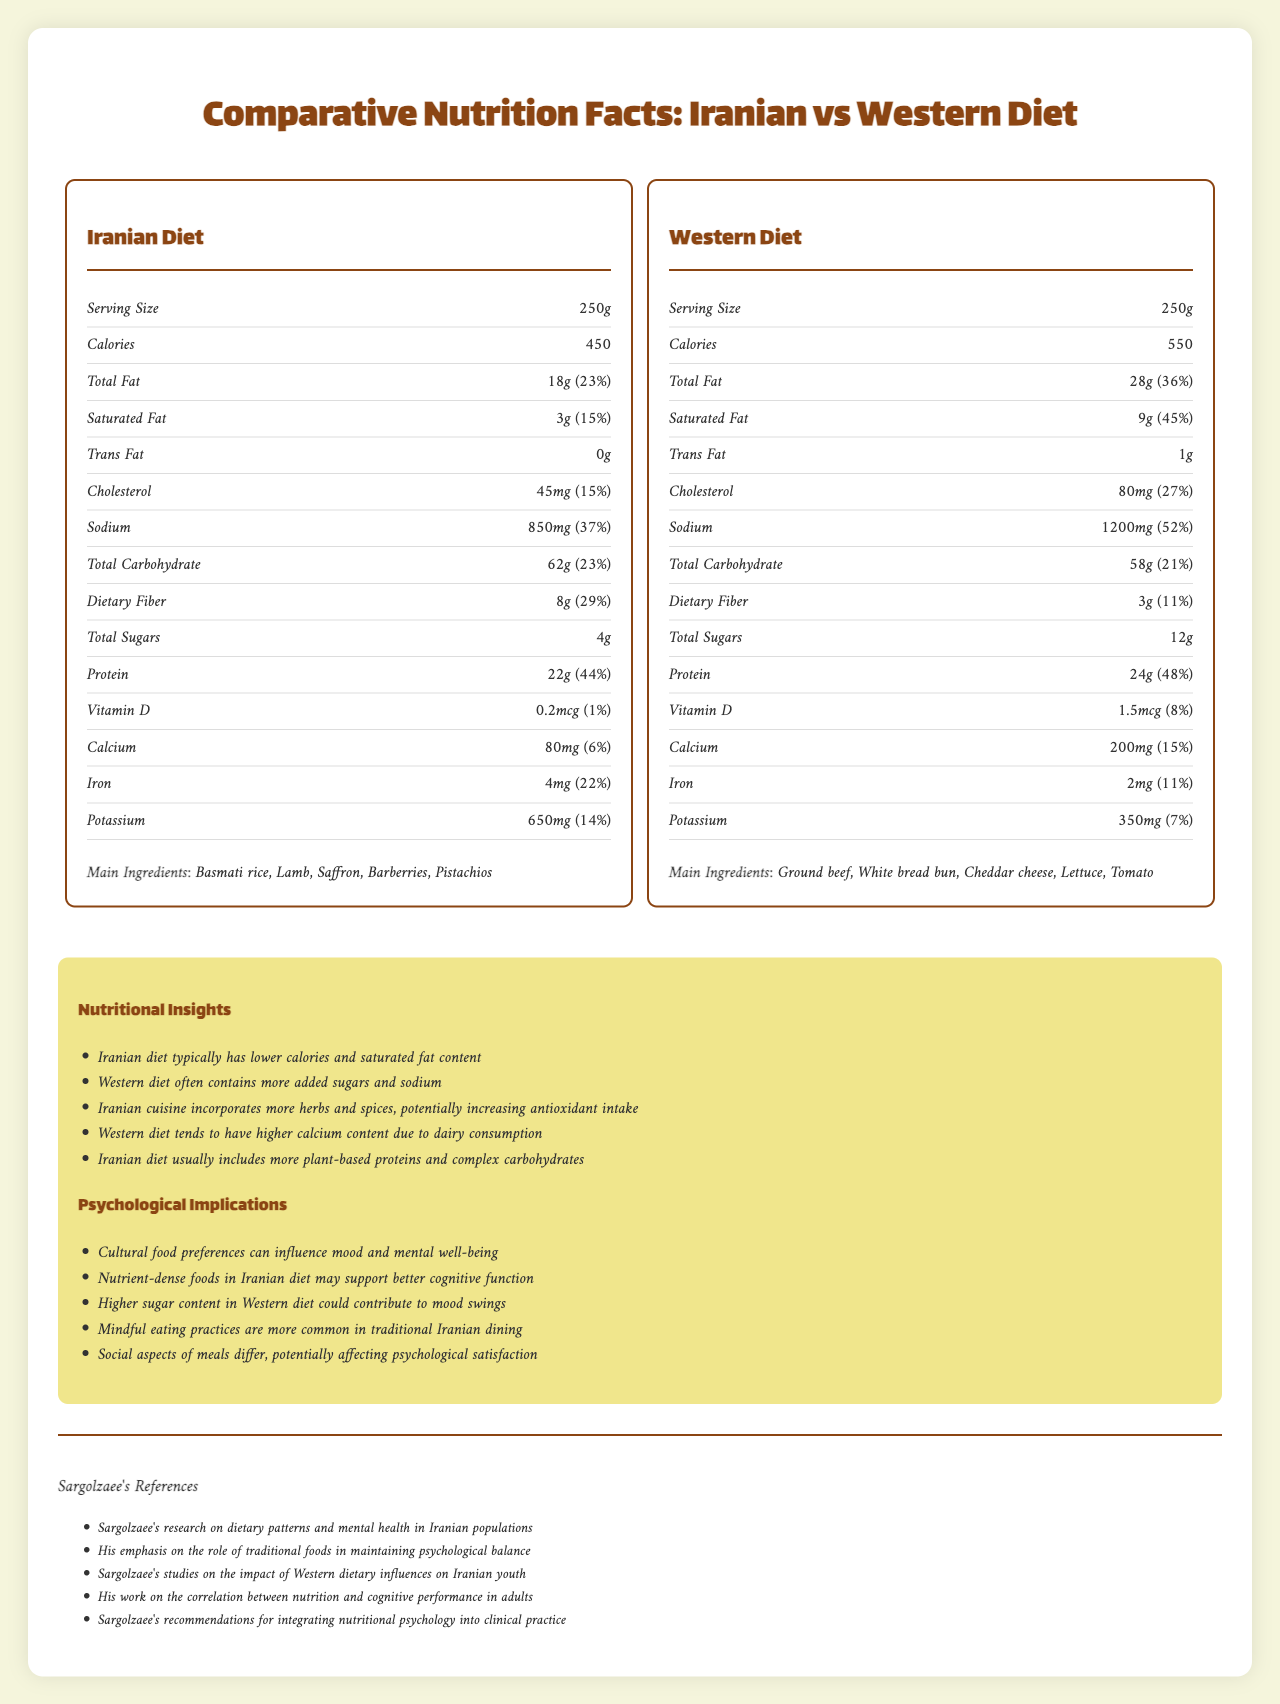what is the serving size for the Iranian diet? The serving size for the Iranian diet is indicated as 250g in the label for the Iranian Diet section.
Answer: 250g What is the amount of protein in the Western diet? The amount of protein in the Western diet is shown to be 24g in the label for the Western Diet section.
Answer: 24g How much dietary fiber is in the Iranian diet? The amount of dietary fiber in the Iranian diet can be found as 8g in the label.
Answer: 8g Which diet has a higher sodium content? A. Iranian Diet B. Western Diet The Western diet has 1200mg of sodium, whereas the Iranian diet has 850mg of sodium, making the Western diet higher in sodium.
Answer: B Which diet tends to include more complex carbohydrates? A. Iranian Diet B. Western Diet C. Both The insights section mentions that the Iranian diet usually includes more complex carbohydrates.
Answer: A Is the amount of trans fat higher in the Western diet compared to the Iranian diet? The Western diet has 1g of trans fat, whereas the Iranian diet has 0g of trans fat.
Answer: Yes Does the Western diet contain any saffron as a main ingredient? Saffron is listed as a main ingredient in the Iranian diet but not in the Western diet.
Answer: No Summarize the main differences highlighted between the Iranian and Western diets in the document. The summary captures the nutritional and psychological comparisons made between the two diets in the document.
Answer: The document outlines nutritional differences between Iranian and Western diets, noting that the Iranian diet typically has lower calories and saturated fat, higher plant-based proteins, and complex carbohydrates. The Western diet contains more added sugars, sodium, and has higher calcium content due to dairy consumption. It also provides insights into the psychological implications of these dietary patterns. What are the psychological implications of higher sugar content in the Western diet? The document mentions that higher sugar content in the Western diet could contribute to mood swings as an implication.
Answer: Contributes to mood swings Which diet includes barberries as a main ingredient? The Main Ingredients section for the Iranian diet lists barberries among its ingredients.
Answer: Iranian Diet How much calcium does the Western diet provide per serving? The label for the Western Diet section shows that it provides 200mg of calcium per serving.
Answer: 200mg What is the daily value percentage of iron in the Iranian diet? The label for the Iranian Diet section mentions that the daily value percentage for iron is 22%.
Answer: 22% How does Sargolzaee suggest integrating nutritional psychology into clinical practice? The document references Sargolzaee's work on integrating nutritional psychology into clinical practice but does not provide specific suggestions on how to do so.
Answer: Not enough information 